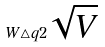Convert formula to latex. <formula><loc_0><loc_0><loc_500><loc_500>W \triangle q 2 \sqrt { V }</formula> 